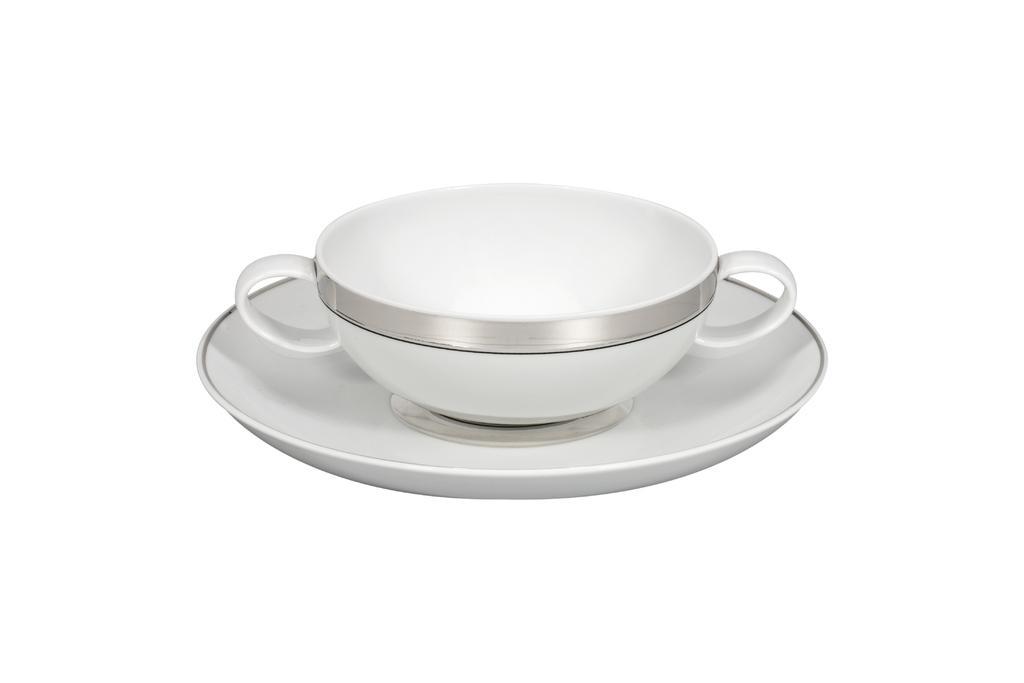In one or two sentences, can you explain what this image depicts? In this image in the center there is one cup and one saucer. 